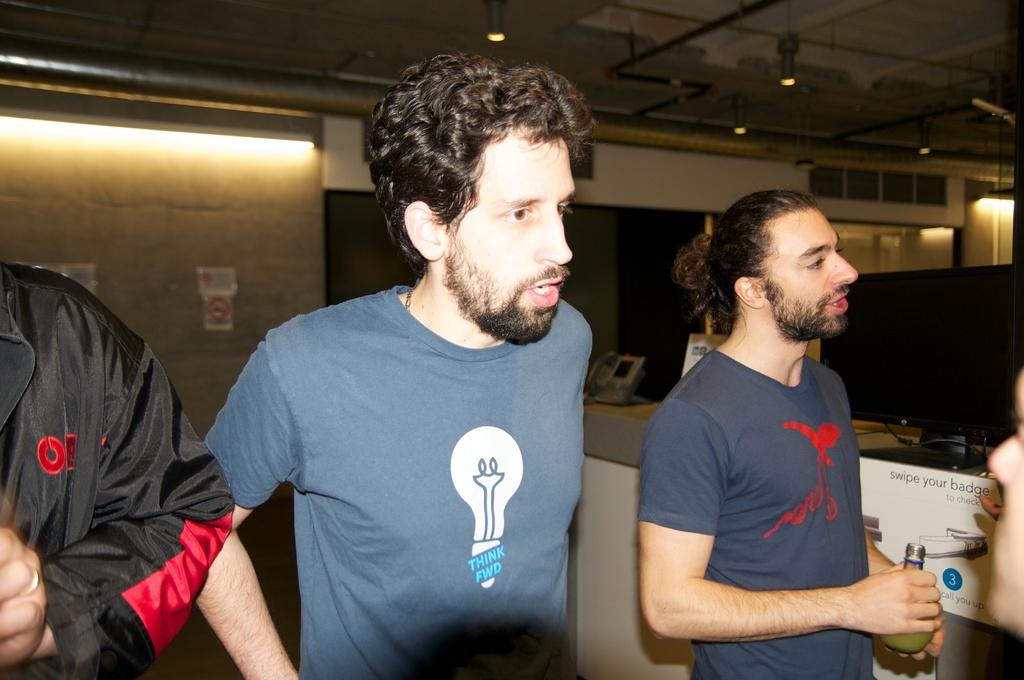What is written on the light bulb on the man's shirt?
Give a very brief answer. Think fwd. What should you swipe?
Your answer should be compact. Badge. 